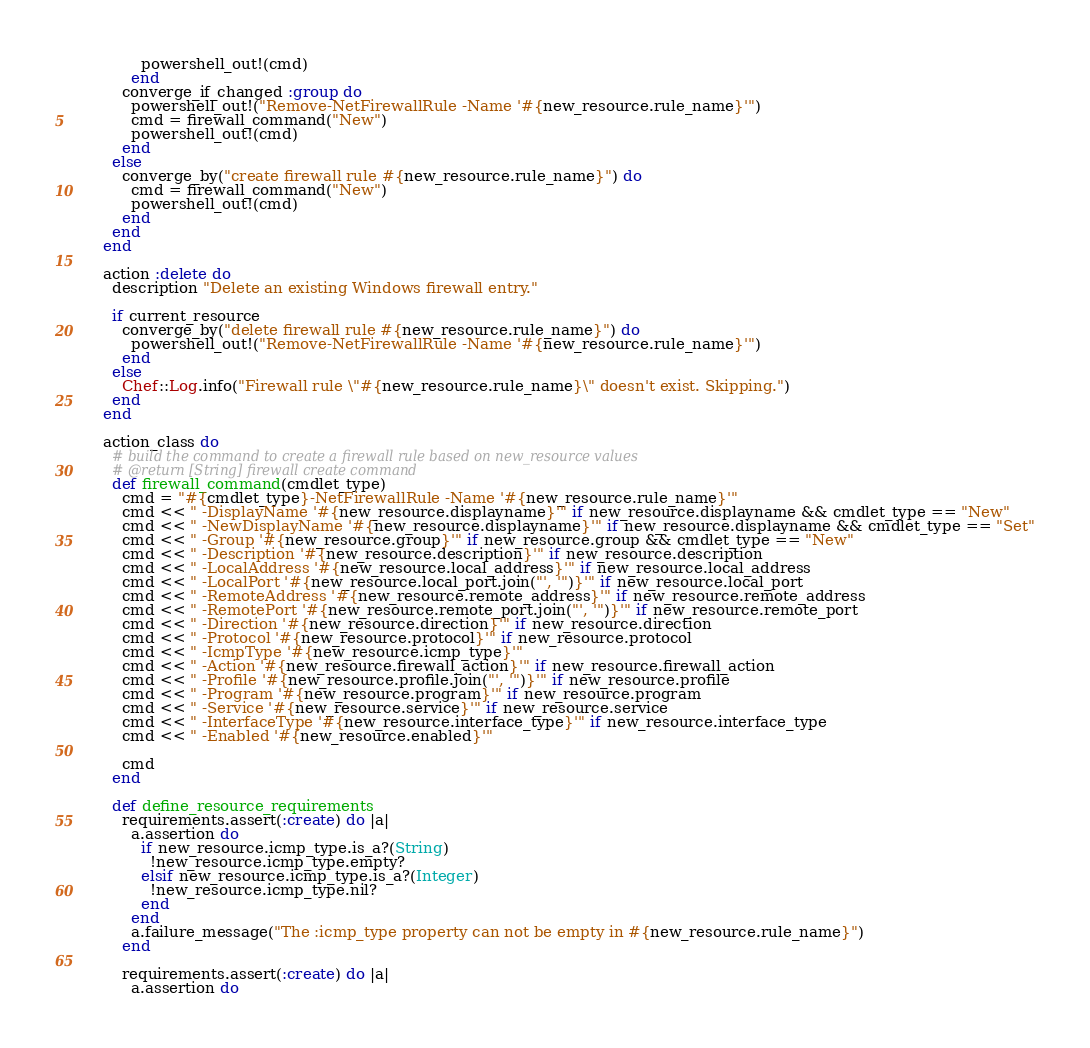Convert code to text. <code><loc_0><loc_0><loc_500><loc_500><_Ruby_>              powershell_out!(cmd)
            end
          converge_if_changed :group do
            powershell_out!("Remove-NetFirewallRule -Name '#{new_resource.rule_name}'")
            cmd = firewall_command("New")
            powershell_out!(cmd)
          end
        else
          converge_by("create firewall rule #{new_resource.rule_name}") do
            cmd = firewall_command("New")
            powershell_out!(cmd)
          end
        end
      end

      action :delete do
        description "Delete an existing Windows firewall entry."

        if current_resource
          converge_by("delete firewall rule #{new_resource.rule_name}") do
            powershell_out!("Remove-NetFirewallRule -Name '#{new_resource.rule_name}'")
          end
        else
          Chef::Log.info("Firewall rule \"#{new_resource.rule_name}\" doesn't exist. Skipping.")
        end
      end

      action_class do
        # build the command to create a firewall rule based on new_resource values
        # @return [String] firewall create command
        def firewall_command(cmdlet_type)
          cmd = "#{cmdlet_type}-NetFirewallRule -Name '#{new_resource.rule_name}'"
          cmd << " -DisplayName '#{new_resource.displayname}'" if new_resource.displayname && cmdlet_type == "New"
          cmd << " -NewDisplayName '#{new_resource.displayname}'" if new_resource.displayname && cmdlet_type == "Set"
          cmd << " -Group '#{new_resource.group}'" if new_resource.group && cmdlet_type == "New"
          cmd << " -Description '#{new_resource.description}'" if new_resource.description
          cmd << " -LocalAddress '#{new_resource.local_address}'" if new_resource.local_address
          cmd << " -LocalPort '#{new_resource.local_port.join("', '")}'" if new_resource.local_port
          cmd << " -RemoteAddress '#{new_resource.remote_address}'" if new_resource.remote_address
          cmd << " -RemotePort '#{new_resource.remote_port.join("', '")}'" if new_resource.remote_port
          cmd << " -Direction '#{new_resource.direction}'" if new_resource.direction
          cmd << " -Protocol '#{new_resource.protocol}'" if new_resource.protocol
          cmd << " -IcmpType '#{new_resource.icmp_type}'"
          cmd << " -Action '#{new_resource.firewall_action}'" if new_resource.firewall_action
          cmd << " -Profile '#{new_resource.profile.join("', '")}'" if new_resource.profile
          cmd << " -Program '#{new_resource.program}'" if new_resource.program
          cmd << " -Service '#{new_resource.service}'" if new_resource.service
          cmd << " -InterfaceType '#{new_resource.interface_type}'" if new_resource.interface_type
          cmd << " -Enabled '#{new_resource.enabled}'"

          cmd
        end

        def define_resource_requirements
          requirements.assert(:create) do |a|
            a.assertion do
              if new_resource.icmp_type.is_a?(String)
                !new_resource.icmp_type.empty?
              elsif new_resource.icmp_type.is_a?(Integer)
                !new_resource.icmp_type.nil?
              end
            end
            a.failure_message("The :icmp_type property can not be empty in #{new_resource.rule_name}")
          end

          requirements.assert(:create) do |a|
            a.assertion do</code> 